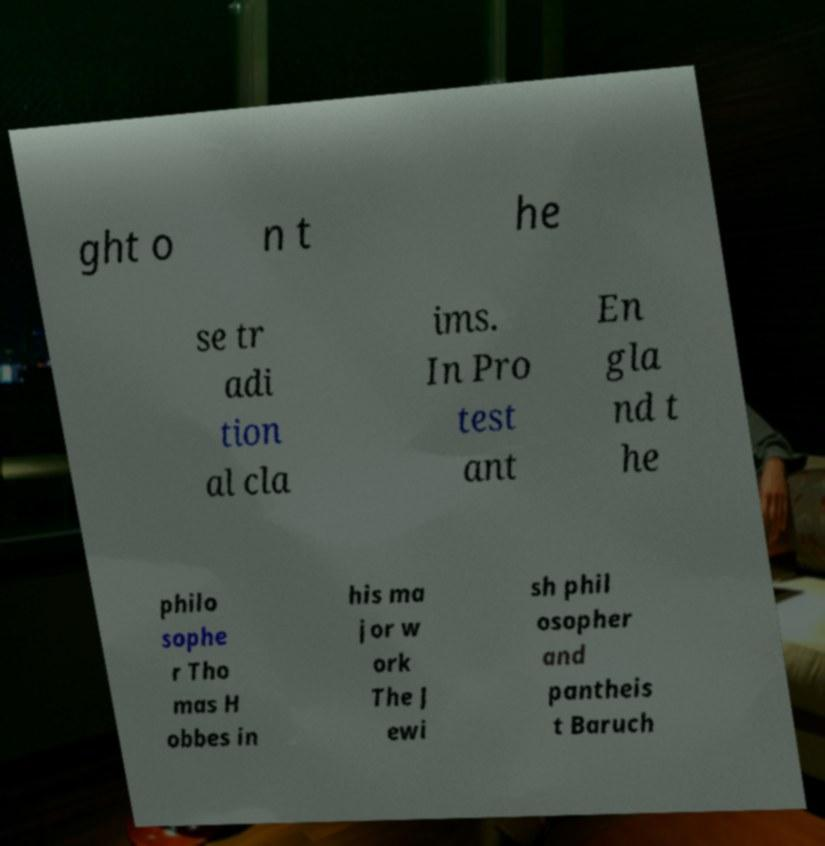Can you accurately transcribe the text from the provided image for me? ght o n t he se tr adi tion al cla ims. In Pro test ant En gla nd t he philo sophe r Tho mas H obbes in his ma jor w ork The J ewi sh phil osopher and pantheis t Baruch 